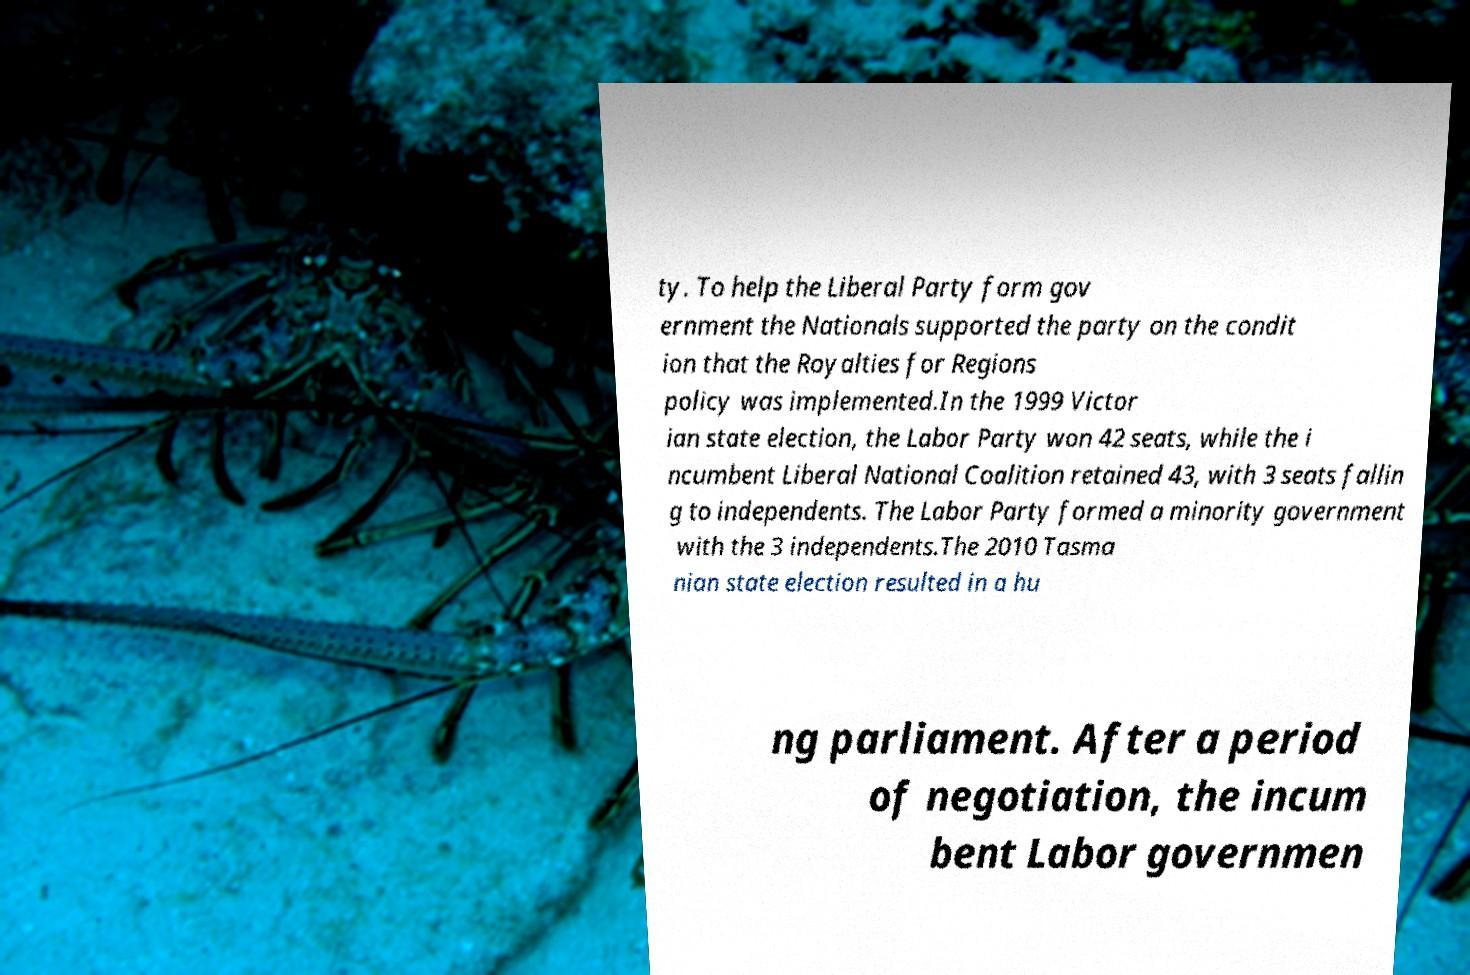There's text embedded in this image that I need extracted. Can you transcribe it verbatim? ty. To help the Liberal Party form gov ernment the Nationals supported the party on the condit ion that the Royalties for Regions policy was implemented.In the 1999 Victor ian state election, the Labor Party won 42 seats, while the i ncumbent Liberal National Coalition retained 43, with 3 seats fallin g to independents. The Labor Party formed a minority government with the 3 independents.The 2010 Tasma nian state election resulted in a hu ng parliament. After a period of negotiation, the incum bent Labor governmen 